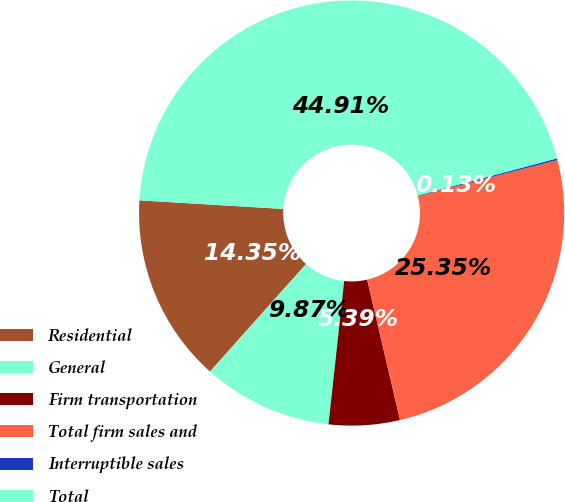Convert chart to OTSL. <chart><loc_0><loc_0><loc_500><loc_500><pie_chart><fcel>Residential<fcel>General<fcel>Firm transportation<fcel>Total firm sales and<fcel>Interruptible sales<fcel>Total<nl><fcel>14.35%<fcel>9.87%<fcel>5.39%<fcel>25.35%<fcel>0.13%<fcel>44.91%<nl></chart> 